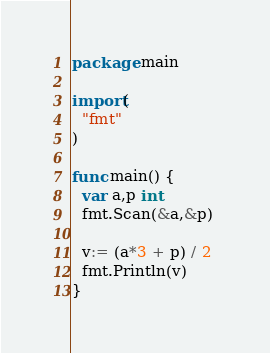Convert code to text. <code><loc_0><loc_0><loc_500><loc_500><_Go_>package main

import(
  "fmt"
)

func main() {
  var a,p int
  fmt.Scan(&a,&p)
  
  v:= (a*3 + p) / 2 
  fmt.Println(v)
}</code> 